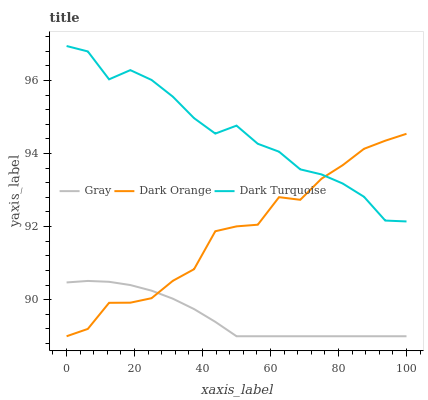Does Gray have the minimum area under the curve?
Answer yes or no. Yes. Does Dark Turquoise have the maximum area under the curve?
Answer yes or no. Yes. Does Dark Orange have the minimum area under the curve?
Answer yes or no. No. Does Dark Orange have the maximum area under the curve?
Answer yes or no. No. Is Gray the smoothest?
Answer yes or no. Yes. Is Dark Orange the roughest?
Answer yes or no. Yes. Is Dark Turquoise the smoothest?
Answer yes or no. No. Is Dark Turquoise the roughest?
Answer yes or no. No. Does Dark Turquoise have the lowest value?
Answer yes or no. No. Does Dark Turquoise have the highest value?
Answer yes or no. Yes. Does Dark Orange have the highest value?
Answer yes or no. No. Is Gray less than Dark Turquoise?
Answer yes or no. Yes. Is Dark Turquoise greater than Gray?
Answer yes or no. Yes. Does Dark Turquoise intersect Dark Orange?
Answer yes or no. Yes. Is Dark Turquoise less than Dark Orange?
Answer yes or no. No. Is Dark Turquoise greater than Dark Orange?
Answer yes or no. No. Does Gray intersect Dark Turquoise?
Answer yes or no. No. 